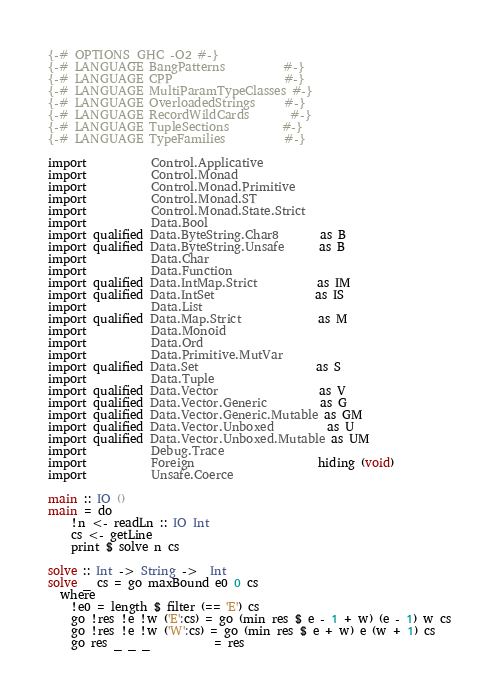Convert code to text. <code><loc_0><loc_0><loc_500><loc_500><_Haskell_>{-# OPTIONS_GHC -O2 #-}
{-# LANGUAGE BangPatterns          #-}
{-# LANGUAGE CPP                   #-}
{-# LANGUAGE MultiParamTypeClasses #-}
{-# LANGUAGE OverloadedStrings     #-}
{-# LANGUAGE RecordWildCards       #-}
{-# LANGUAGE TupleSections         #-}
{-# LANGUAGE TypeFamilies          #-}

import           Control.Applicative
import           Control.Monad
import           Control.Monad.Primitive
import           Control.Monad.ST
import           Control.Monad.State.Strict
import           Data.Bool
import qualified Data.ByteString.Char8       as B
import qualified Data.ByteString.Unsafe      as B
import           Data.Char
import           Data.Function
import qualified Data.IntMap.Strict          as IM
import qualified Data.IntSet                 as IS
import           Data.List
import qualified Data.Map.Strict             as M
import           Data.Monoid
import           Data.Ord
import           Data.Primitive.MutVar
import qualified Data.Set                    as S
import           Data.Tuple
import qualified Data.Vector                 as V
import qualified Data.Vector.Generic         as G
import qualified Data.Vector.Generic.Mutable as GM
import qualified Data.Vector.Unboxed         as U
import qualified Data.Vector.Unboxed.Mutable as UM
import           Debug.Trace
import           Foreign                     hiding (void)
import           Unsafe.Coerce

main :: IO ()
main = do
    !n <- readLn :: IO Int
    cs <- getLine
    print $ solve n cs

solve :: Int -> String ->  Int
solve _ cs = go maxBound e0 0 cs
  where
    !e0 = length $ filter (== 'E') cs
    go !res !e !w ('E':cs) = go (min res $ e - 1 + w) (e - 1) w cs
    go !res !e !w ('W':cs) = go (min res $ e + w) e (w + 1) cs
    go res _ _ _           = res
</code> 